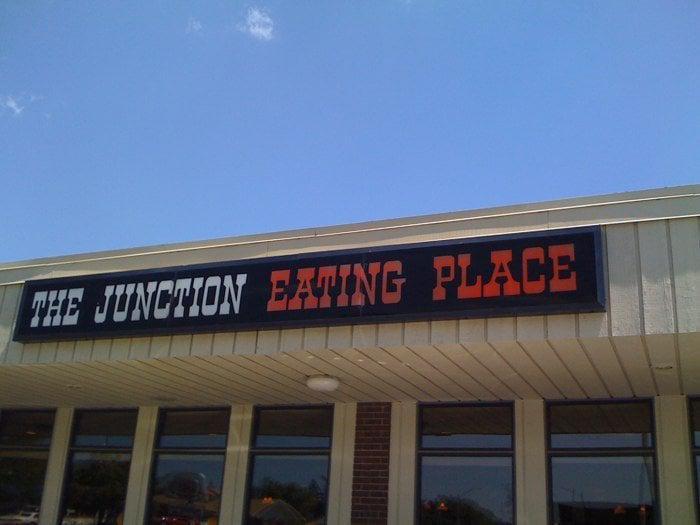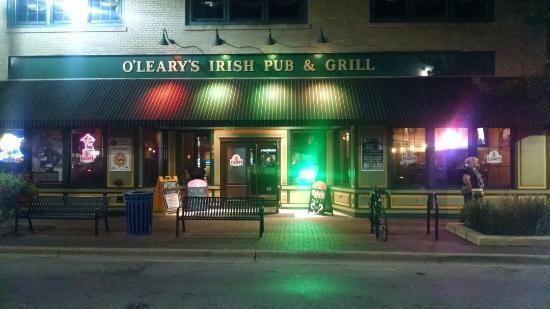The first image is the image on the left, the second image is the image on the right. Evaluate the accuracy of this statement regarding the images: "One image shows a flat-topped building with a sign lettered in two colors above a row of six rectangular windows.". Is it true? Answer yes or no. Yes. The first image is the image on the left, the second image is the image on the right. Considering the images on both sides, is "The image shows the outside of a restaurant with it's name displayed near the top of the building" valid? Answer yes or no. Yes. 